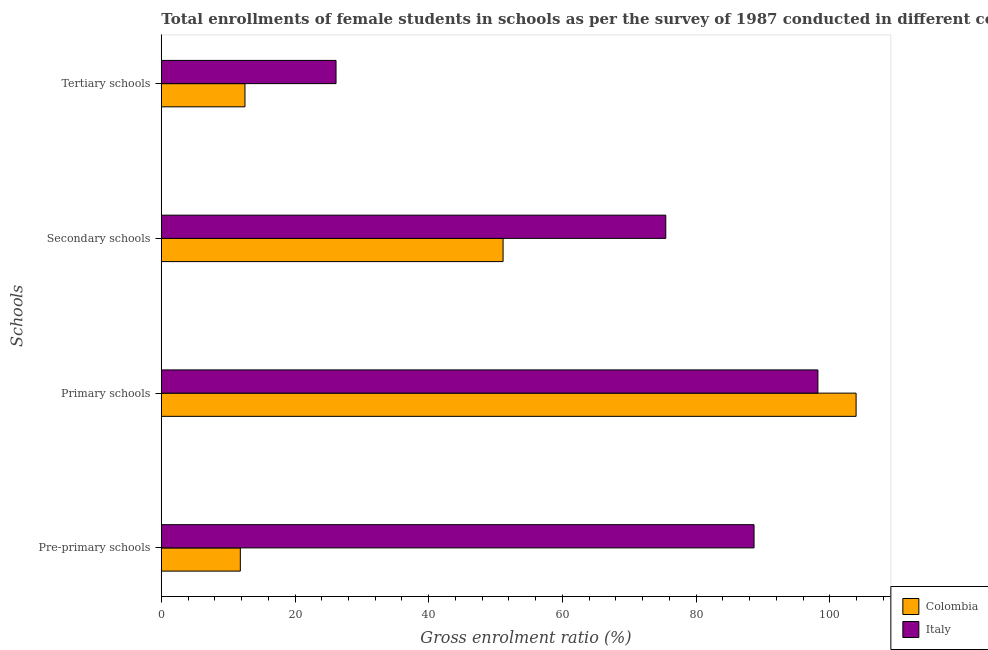Are the number of bars on each tick of the Y-axis equal?
Your response must be concise. Yes. How many bars are there on the 4th tick from the top?
Your answer should be compact. 2. How many bars are there on the 1st tick from the bottom?
Give a very brief answer. 2. What is the label of the 3rd group of bars from the top?
Your answer should be very brief. Primary schools. What is the gross enrolment ratio(female) in primary schools in Colombia?
Offer a very short reply. 103.93. Across all countries, what is the maximum gross enrolment ratio(female) in tertiary schools?
Give a very brief answer. 26.13. Across all countries, what is the minimum gross enrolment ratio(female) in tertiary schools?
Make the answer very short. 12.51. What is the total gross enrolment ratio(female) in pre-primary schools in the graph?
Your answer should be compact. 100.48. What is the difference between the gross enrolment ratio(female) in secondary schools in Italy and that in Colombia?
Make the answer very short. 24.34. What is the difference between the gross enrolment ratio(female) in primary schools in Colombia and the gross enrolment ratio(female) in pre-primary schools in Italy?
Your response must be concise. 15.27. What is the average gross enrolment ratio(female) in pre-primary schools per country?
Offer a terse response. 50.24. What is the difference between the gross enrolment ratio(female) in secondary schools and gross enrolment ratio(female) in pre-primary schools in Italy?
Offer a very short reply. -13.2. What is the ratio of the gross enrolment ratio(female) in secondary schools in Italy to that in Colombia?
Provide a short and direct response. 1.48. Is the gross enrolment ratio(female) in primary schools in Colombia less than that in Italy?
Your answer should be very brief. No. What is the difference between the highest and the second highest gross enrolment ratio(female) in secondary schools?
Offer a terse response. 24.34. What is the difference between the highest and the lowest gross enrolment ratio(female) in tertiary schools?
Provide a short and direct response. 13.62. In how many countries, is the gross enrolment ratio(female) in tertiary schools greater than the average gross enrolment ratio(female) in tertiary schools taken over all countries?
Keep it short and to the point. 1. Is the sum of the gross enrolment ratio(female) in primary schools in Colombia and Italy greater than the maximum gross enrolment ratio(female) in secondary schools across all countries?
Ensure brevity in your answer.  Yes. Is it the case that in every country, the sum of the gross enrolment ratio(female) in tertiary schools and gross enrolment ratio(female) in primary schools is greater than the sum of gross enrolment ratio(female) in secondary schools and gross enrolment ratio(female) in pre-primary schools?
Keep it short and to the point. No. What does the 1st bar from the top in Pre-primary schools represents?
Offer a terse response. Italy. Is it the case that in every country, the sum of the gross enrolment ratio(female) in pre-primary schools and gross enrolment ratio(female) in primary schools is greater than the gross enrolment ratio(female) in secondary schools?
Offer a terse response. Yes. Are all the bars in the graph horizontal?
Offer a terse response. Yes. Where does the legend appear in the graph?
Keep it short and to the point. Bottom right. How are the legend labels stacked?
Ensure brevity in your answer.  Vertical. What is the title of the graph?
Provide a succinct answer. Total enrollments of female students in schools as per the survey of 1987 conducted in different countries. What is the label or title of the X-axis?
Ensure brevity in your answer.  Gross enrolment ratio (%). What is the label or title of the Y-axis?
Your answer should be compact. Schools. What is the Gross enrolment ratio (%) of Colombia in Pre-primary schools?
Make the answer very short. 11.82. What is the Gross enrolment ratio (%) of Italy in Pre-primary schools?
Offer a very short reply. 88.66. What is the Gross enrolment ratio (%) of Colombia in Primary schools?
Make the answer very short. 103.93. What is the Gross enrolment ratio (%) in Italy in Primary schools?
Offer a terse response. 98.21. What is the Gross enrolment ratio (%) in Colombia in Secondary schools?
Provide a succinct answer. 51.12. What is the Gross enrolment ratio (%) of Italy in Secondary schools?
Make the answer very short. 75.46. What is the Gross enrolment ratio (%) in Colombia in Tertiary schools?
Provide a succinct answer. 12.51. What is the Gross enrolment ratio (%) in Italy in Tertiary schools?
Your response must be concise. 26.13. Across all Schools, what is the maximum Gross enrolment ratio (%) of Colombia?
Offer a very short reply. 103.93. Across all Schools, what is the maximum Gross enrolment ratio (%) in Italy?
Offer a terse response. 98.21. Across all Schools, what is the minimum Gross enrolment ratio (%) in Colombia?
Keep it short and to the point. 11.82. Across all Schools, what is the minimum Gross enrolment ratio (%) in Italy?
Your answer should be compact. 26.13. What is the total Gross enrolment ratio (%) in Colombia in the graph?
Provide a succinct answer. 179.38. What is the total Gross enrolment ratio (%) in Italy in the graph?
Your answer should be very brief. 288.46. What is the difference between the Gross enrolment ratio (%) of Colombia in Pre-primary schools and that in Primary schools?
Your answer should be very brief. -92.11. What is the difference between the Gross enrolment ratio (%) of Italy in Pre-primary schools and that in Primary schools?
Provide a succinct answer. -9.55. What is the difference between the Gross enrolment ratio (%) in Colombia in Pre-primary schools and that in Secondary schools?
Give a very brief answer. -39.3. What is the difference between the Gross enrolment ratio (%) in Italy in Pre-primary schools and that in Secondary schools?
Your response must be concise. 13.2. What is the difference between the Gross enrolment ratio (%) in Colombia in Pre-primary schools and that in Tertiary schools?
Give a very brief answer. -0.7. What is the difference between the Gross enrolment ratio (%) in Italy in Pre-primary schools and that in Tertiary schools?
Your response must be concise. 62.53. What is the difference between the Gross enrolment ratio (%) of Colombia in Primary schools and that in Secondary schools?
Offer a terse response. 52.81. What is the difference between the Gross enrolment ratio (%) in Italy in Primary schools and that in Secondary schools?
Your answer should be very brief. 22.75. What is the difference between the Gross enrolment ratio (%) in Colombia in Primary schools and that in Tertiary schools?
Your answer should be compact. 91.41. What is the difference between the Gross enrolment ratio (%) in Italy in Primary schools and that in Tertiary schools?
Your answer should be compact. 72.08. What is the difference between the Gross enrolment ratio (%) of Colombia in Secondary schools and that in Tertiary schools?
Keep it short and to the point. 38.61. What is the difference between the Gross enrolment ratio (%) of Italy in Secondary schools and that in Tertiary schools?
Give a very brief answer. 49.32. What is the difference between the Gross enrolment ratio (%) of Colombia in Pre-primary schools and the Gross enrolment ratio (%) of Italy in Primary schools?
Provide a succinct answer. -86.39. What is the difference between the Gross enrolment ratio (%) of Colombia in Pre-primary schools and the Gross enrolment ratio (%) of Italy in Secondary schools?
Give a very brief answer. -63.64. What is the difference between the Gross enrolment ratio (%) in Colombia in Pre-primary schools and the Gross enrolment ratio (%) in Italy in Tertiary schools?
Provide a short and direct response. -14.32. What is the difference between the Gross enrolment ratio (%) in Colombia in Primary schools and the Gross enrolment ratio (%) in Italy in Secondary schools?
Your answer should be very brief. 28.47. What is the difference between the Gross enrolment ratio (%) in Colombia in Primary schools and the Gross enrolment ratio (%) in Italy in Tertiary schools?
Provide a succinct answer. 77.79. What is the difference between the Gross enrolment ratio (%) of Colombia in Secondary schools and the Gross enrolment ratio (%) of Italy in Tertiary schools?
Keep it short and to the point. 24.99. What is the average Gross enrolment ratio (%) of Colombia per Schools?
Give a very brief answer. 44.84. What is the average Gross enrolment ratio (%) of Italy per Schools?
Keep it short and to the point. 72.12. What is the difference between the Gross enrolment ratio (%) in Colombia and Gross enrolment ratio (%) in Italy in Pre-primary schools?
Make the answer very short. -76.84. What is the difference between the Gross enrolment ratio (%) in Colombia and Gross enrolment ratio (%) in Italy in Primary schools?
Offer a terse response. 5.71. What is the difference between the Gross enrolment ratio (%) in Colombia and Gross enrolment ratio (%) in Italy in Secondary schools?
Offer a very short reply. -24.34. What is the difference between the Gross enrolment ratio (%) of Colombia and Gross enrolment ratio (%) of Italy in Tertiary schools?
Provide a short and direct response. -13.62. What is the ratio of the Gross enrolment ratio (%) in Colombia in Pre-primary schools to that in Primary schools?
Your answer should be compact. 0.11. What is the ratio of the Gross enrolment ratio (%) of Italy in Pre-primary schools to that in Primary schools?
Offer a terse response. 0.9. What is the ratio of the Gross enrolment ratio (%) of Colombia in Pre-primary schools to that in Secondary schools?
Offer a very short reply. 0.23. What is the ratio of the Gross enrolment ratio (%) in Italy in Pre-primary schools to that in Secondary schools?
Make the answer very short. 1.18. What is the ratio of the Gross enrolment ratio (%) in Italy in Pre-primary schools to that in Tertiary schools?
Make the answer very short. 3.39. What is the ratio of the Gross enrolment ratio (%) of Colombia in Primary schools to that in Secondary schools?
Provide a succinct answer. 2.03. What is the ratio of the Gross enrolment ratio (%) in Italy in Primary schools to that in Secondary schools?
Your response must be concise. 1.3. What is the ratio of the Gross enrolment ratio (%) in Colombia in Primary schools to that in Tertiary schools?
Your response must be concise. 8.31. What is the ratio of the Gross enrolment ratio (%) in Italy in Primary schools to that in Tertiary schools?
Keep it short and to the point. 3.76. What is the ratio of the Gross enrolment ratio (%) in Colombia in Secondary schools to that in Tertiary schools?
Give a very brief answer. 4.09. What is the ratio of the Gross enrolment ratio (%) of Italy in Secondary schools to that in Tertiary schools?
Offer a very short reply. 2.89. What is the difference between the highest and the second highest Gross enrolment ratio (%) of Colombia?
Make the answer very short. 52.81. What is the difference between the highest and the second highest Gross enrolment ratio (%) in Italy?
Your response must be concise. 9.55. What is the difference between the highest and the lowest Gross enrolment ratio (%) in Colombia?
Provide a succinct answer. 92.11. What is the difference between the highest and the lowest Gross enrolment ratio (%) of Italy?
Ensure brevity in your answer.  72.08. 